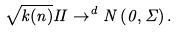Convert formula to latex. <formula><loc_0><loc_0><loc_500><loc_500>\sqrt { k ( n ) } I I \rightarrow ^ { d } N \left ( 0 , \Sigma \right ) .</formula> 